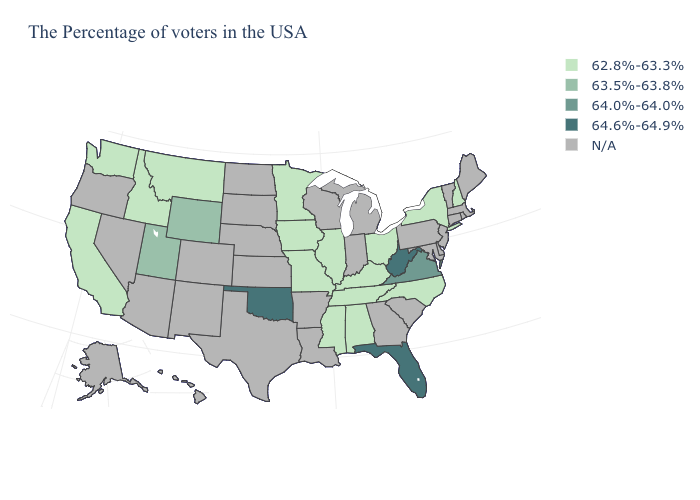What is the value of Florida?
Be succinct. 64.6%-64.9%. What is the value of Wisconsin?
Answer briefly. N/A. Which states have the highest value in the USA?
Answer briefly. West Virginia, Florida, Oklahoma. Does the first symbol in the legend represent the smallest category?
Answer briefly. Yes. What is the value of South Dakota?
Be succinct. N/A. Name the states that have a value in the range N/A?
Concise answer only. Maine, Massachusetts, Rhode Island, Vermont, Connecticut, New Jersey, Delaware, Maryland, Pennsylvania, South Carolina, Georgia, Michigan, Indiana, Wisconsin, Louisiana, Arkansas, Kansas, Nebraska, Texas, South Dakota, North Dakota, Colorado, New Mexico, Arizona, Nevada, Oregon, Alaska, Hawaii. What is the highest value in states that border Mississippi?
Be succinct. 62.8%-63.3%. What is the lowest value in states that border Vermont?
Be succinct. 62.8%-63.3%. Name the states that have a value in the range 63.5%-63.8%?
Concise answer only. Wyoming, Utah. What is the value of Ohio?
Short answer required. 62.8%-63.3%. What is the lowest value in states that border Maine?
Give a very brief answer. 62.8%-63.3%. What is the value of Florida?
Concise answer only. 64.6%-64.9%. What is the highest value in the South ?
Quick response, please. 64.6%-64.9%. Name the states that have a value in the range N/A?
Give a very brief answer. Maine, Massachusetts, Rhode Island, Vermont, Connecticut, New Jersey, Delaware, Maryland, Pennsylvania, South Carolina, Georgia, Michigan, Indiana, Wisconsin, Louisiana, Arkansas, Kansas, Nebraska, Texas, South Dakota, North Dakota, Colorado, New Mexico, Arizona, Nevada, Oregon, Alaska, Hawaii. 